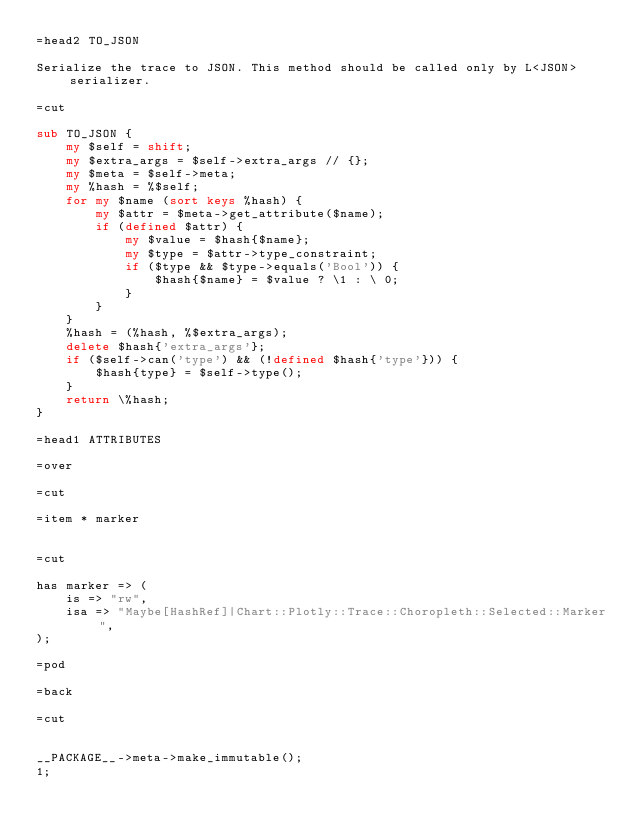Convert code to text. <code><loc_0><loc_0><loc_500><loc_500><_Perl_>=head2 TO_JSON

Serialize the trace to JSON. This method should be called only by L<JSON> serializer.

=cut

sub TO_JSON {
    my $self = shift; 
    my $extra_args = $self->extra_args // {};
    my $meta = $self->meta;
    my %hash = %$self;
    for my $name (sort keys %hash) {
        my $attr = $meta->get_attribute($name);
        if (defined $attr) {
            my $value = $hash{$name};
            my $type = $attr->type_constraint;
            if ($type && $type->equals('Bool')) {
                $hash{$name} = $value ? \1 : \ 0;
            }
        }
    }
    %hash = (%hash, %$extra_args);
    delete $hash{'extra_args'};
    if ($self->can('type') && (!defined $hash{'type'})) {
        $hash{type} = $self->type();
    }
    return \%hash;
}

=head1 ATTRIBUTES

=over

=cut

=item * marker


=cut

has marker => (
    is => "rw",
    isa => "Maybe[HashRef]|Chart::Plotly::Trace::Choropleth::Selected::Marker",
);

=pod

=back

=cut


__PACKAGE__->meta->make_immutable();
1;
</code> 